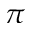Convert formula to latex. <formula><loc_0><loc_0><loc_500><loc_500>\pi</formula> 